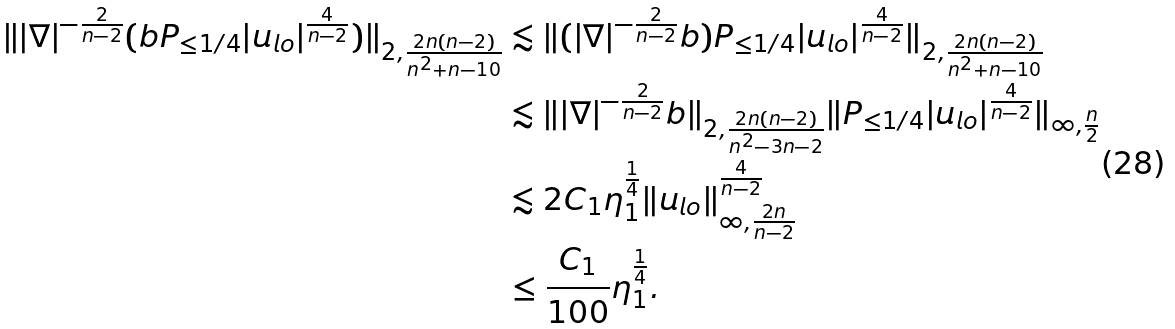<formula> <loc_0><loc_0><loc_500><loc_500>\| | \nabla | ^ { - \frac { 2 } { n - 2 } } ( b P _ { \leq 1 / 4 } | u _ { l o } | ^ { \frac { 4 } { n - 2 } } ) \| _ { 2 , \frac { 2 n ( n - 2 ) } { n ^ { 2 } + n - 1 0 } } & \lesssim \| ( | \nabla | ^ { - \frac { 2 } { n - 2 } } b ) P _ { \leq 1 / 4 } | u _ { l o } | ^ { \frac { 4 } { n - 2 } } \| _ { 2 , \frac { 2 n ( n - 2 ) } { n ^ { 2 } + n - 1 0 } } \\ & \lesssim \| | \nabla | ^ { - \frac { 2 } { n - 2 } } b \| _ { 2 , \frac { 2 n ( n - 2 ) } { n ^ { 2 } - 3 n - 2 } } \| P _ { \leq 1 / 4 } | u _ { l o } | ^ { \frac { 4 } { n - 2 } } \| _ { \infty , \frac { n } { 2 } } \\ & \lesssim 2 C _ { 1 } \eta _ { 1 } ^ { \frac { 1 } { 4 } } \| u _ { l o } \| _ { \infty , \frac { 2 n } { n - 2 } } ^ { \frac { 4 } { n - 2 } } \\ & \leq \frac { C _ { 1 } } { 1 0 0 } \eta _ { 1 } ^ { \frac { 1 } { 4 } } .</formula> 